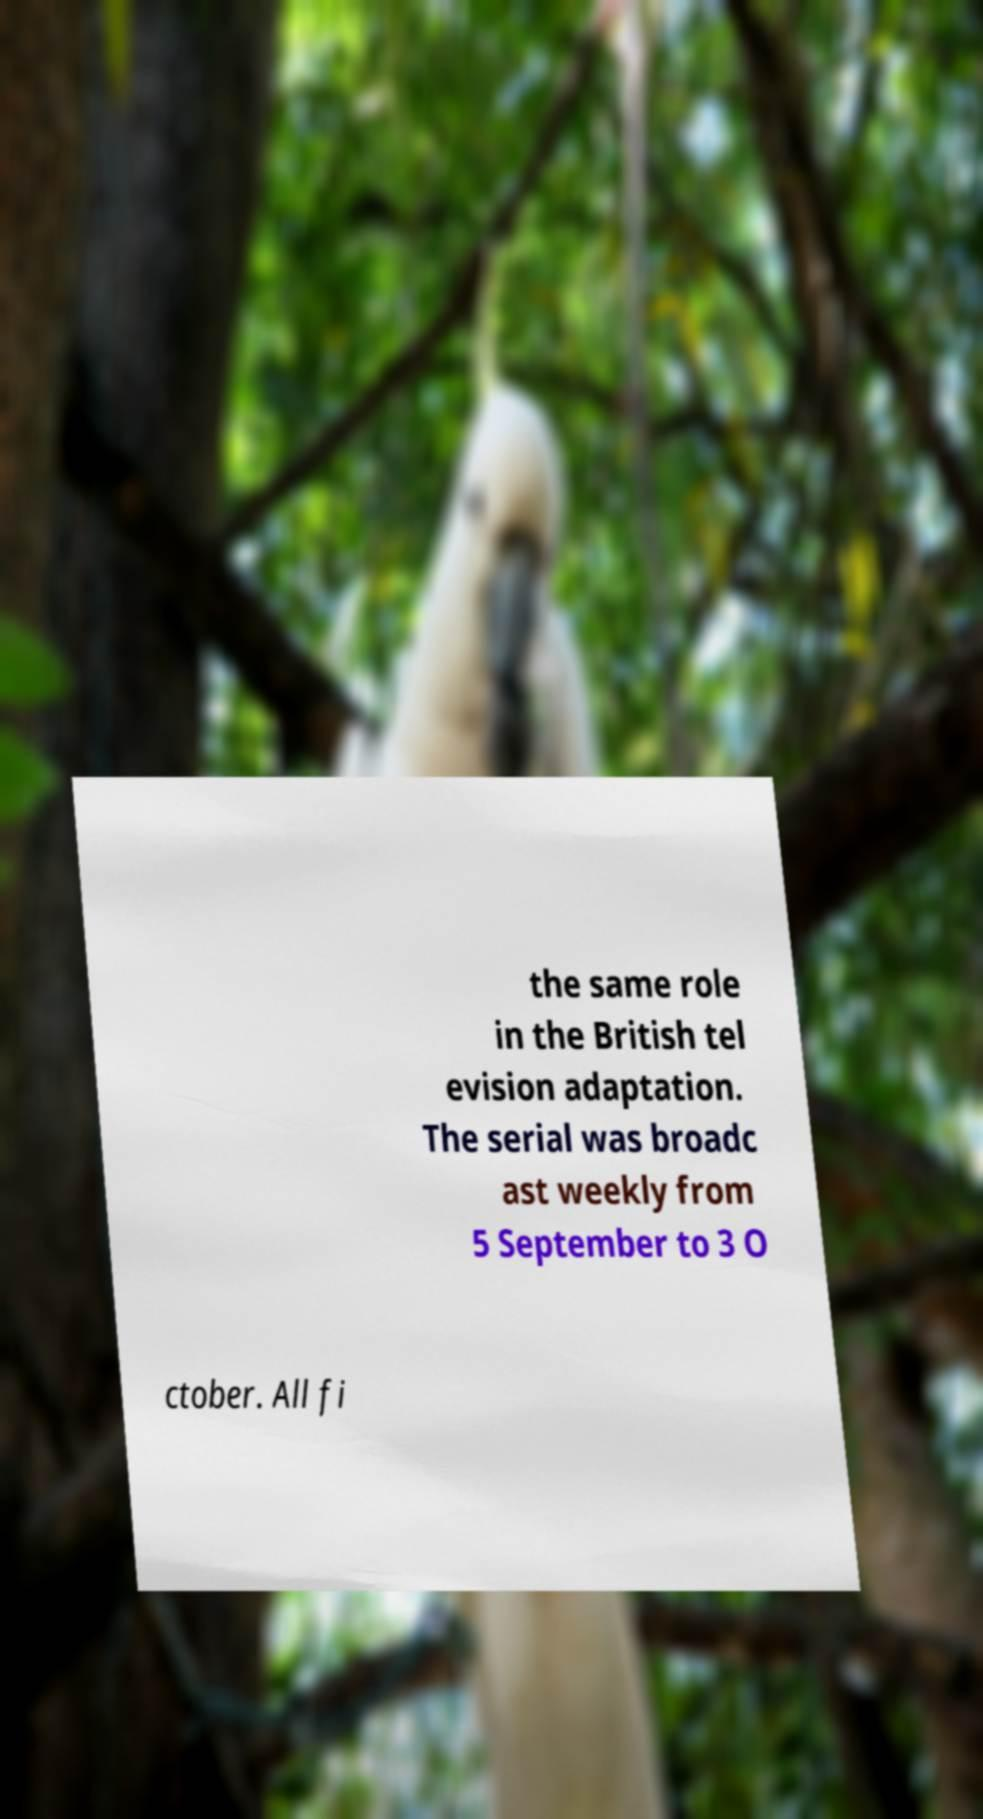Can you read and provide the text displayed in the image?This photo seems to have some interesting text. Can you extract and type it out for me? the same role in the British tel evision adaptation. The serial was broadc ast weekly from 5 September to 3 O ctober. All fi 